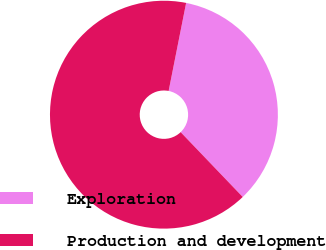Convert chart. <chart><loc_0><loc_0><loc_500><loc_500><pie_chart><fcel>Exploration<fcel>Production and development<nl><fcel>34.72%<fcel>65.28%<nl></chart> 